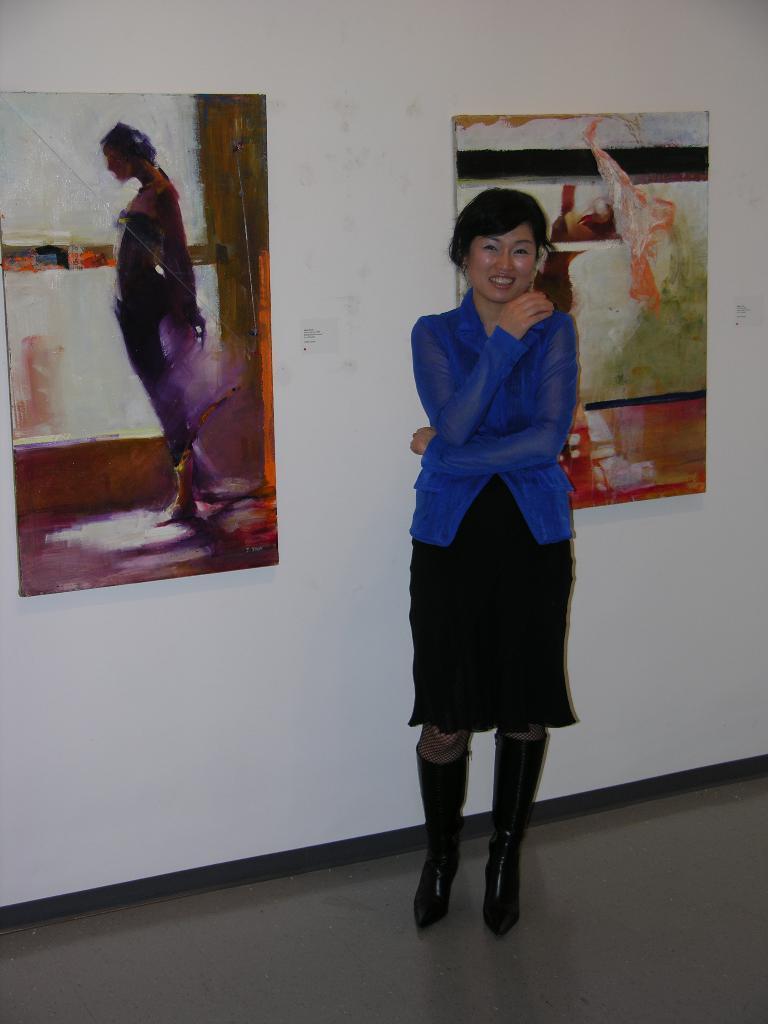How would you summarize this image in a sentence or two? There is a lady standing in the foreground and there are paintings in the background area. 